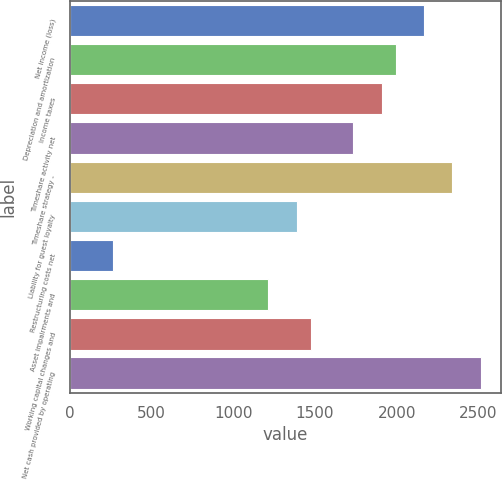<chart> <loc_0><loc_0><loc_500><loc_500><bar_chart><fcel>Net income (loss)<fcel>Depreciation and amortization<fcel>Income taxes<fcel>Timeshare activity net<fcel>Timeshare strategy -<fcel>Liability for guest loyalty<fcel>Restructuring costs net<fcel>Asset impairments and<fcel>Working capital changes and<fcel>Net cash provided by operating<nl><fcel>2167.78<fcel>1994.48<fcel>1907.83<fcel>1734.53<fcel>2341.08<fcel>1387.93<fcel>261.48<fcel>1214.63<fcel>1474.58<fcel>2514.38<nl></chart> 